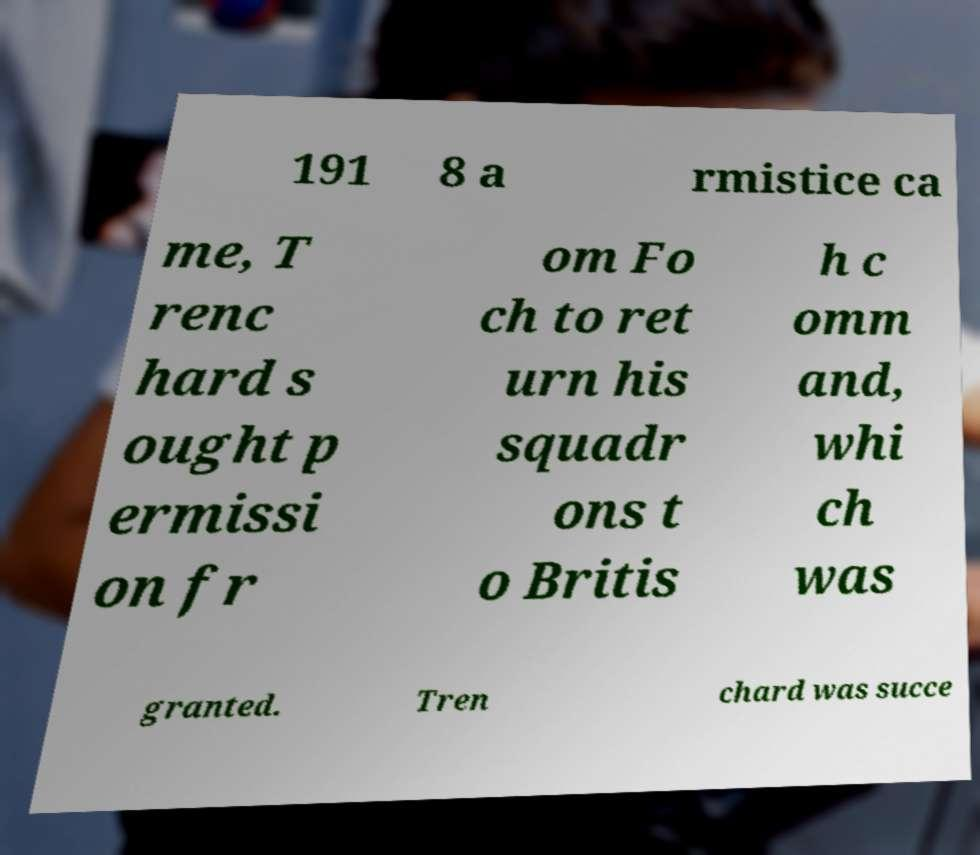Could you assist in decoding the text presented in this image and type it out clearly? 191 8 a rmistice ca me, T renc hard s ought p ermissi on fr om Fo ch to ret urn his squadr ons t o Britis h c omm and, whi ch was granted. Tren chard was succe 